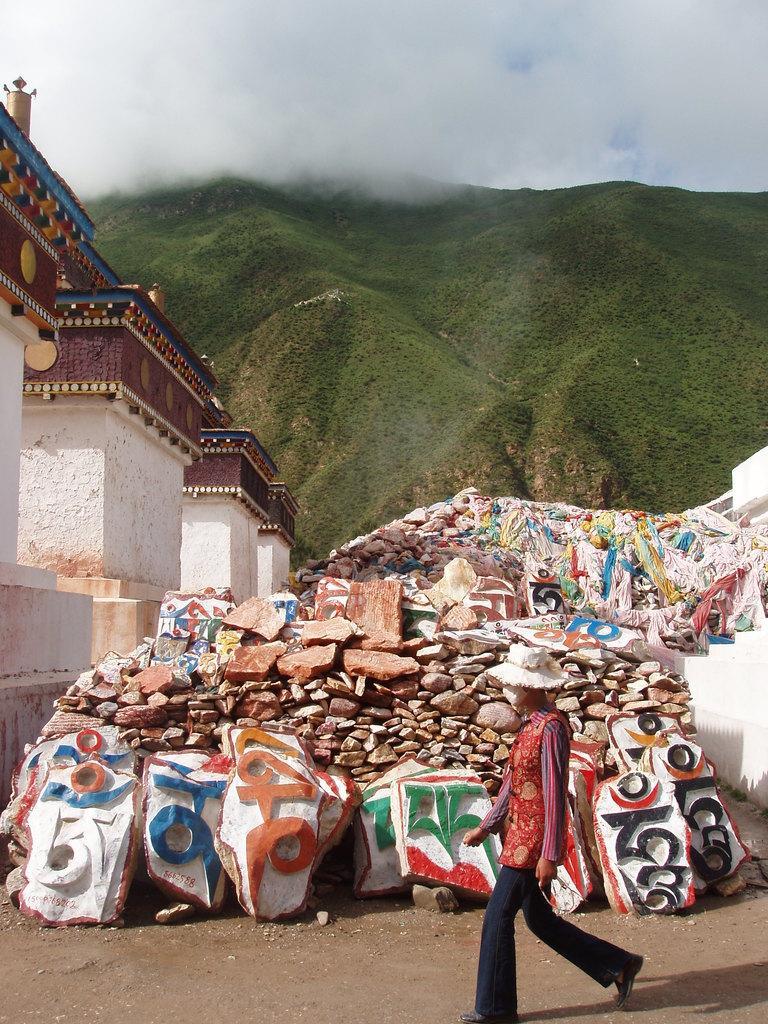Please provide a concise description of this image. In this picture there is a person on the right side of the image, he is wearing a hat, there are rocks in the center of the image and there are pillars on the left side of the image, there are mountains at the top side of the image. 